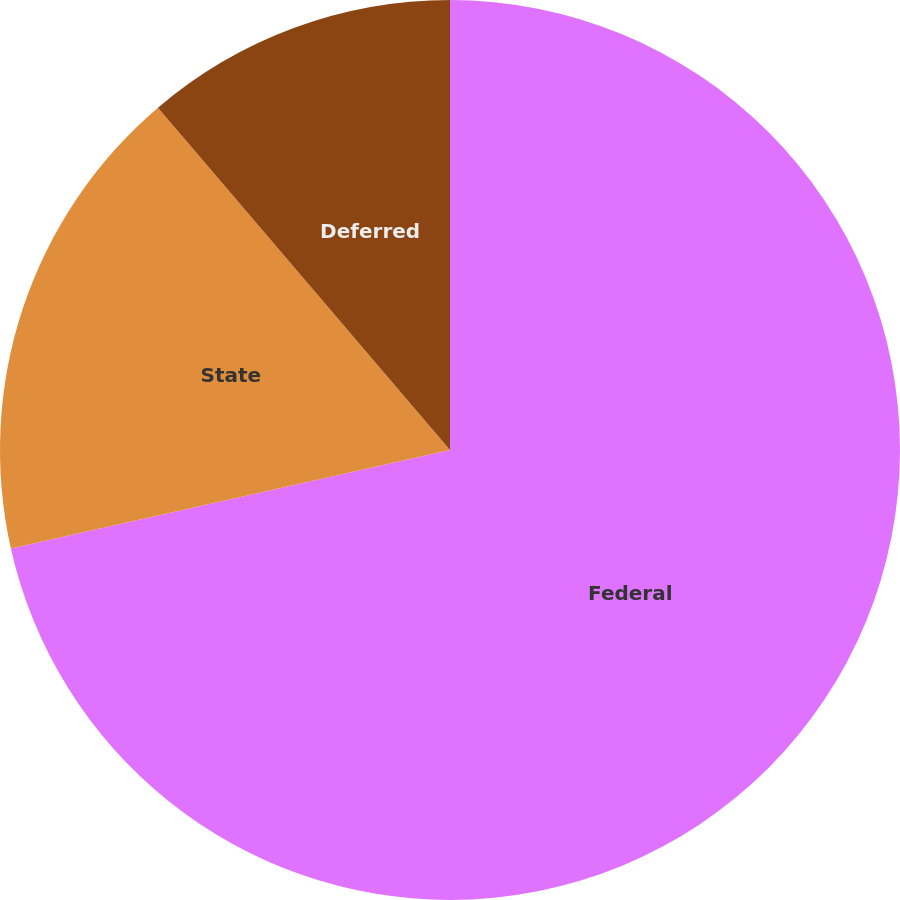Convert chart to OTSL. <chart><loc_0><loc_0><loc_500><loc_500><pie_chart><fcel>Federal<fcel>State<fcel>Deferred<nl><fcel>71.49%<fcel>17.27%<fcel>11.24%<nl></chart> 